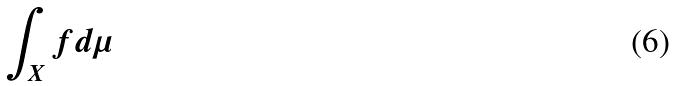Convert formula to latex. <formula><loc_0><loc_0><loc_500><loc_500>\int _ { X } f d \mu</formula> 